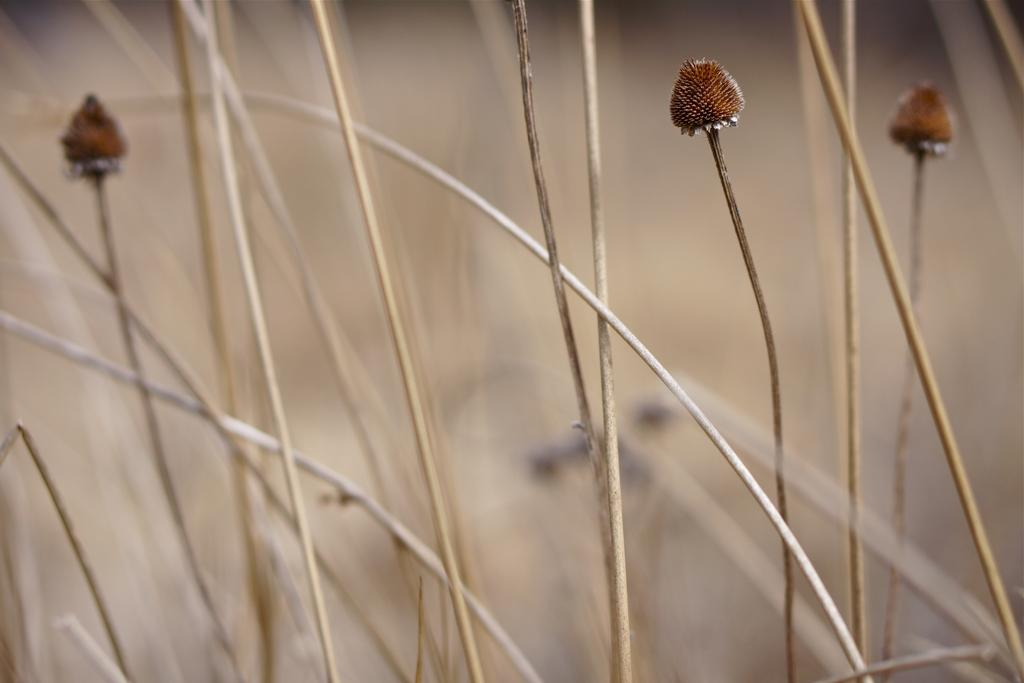How many flower buds can be seen in the image? There are three flower buds in the image. What can be observed in the background of the image? The background of the image is blurry. What type of structure can be seen in the background of the image? There is no structure visible in the background of the image; it is blurry. Where might the flowers be resting in the image? The flowers are not resting in the image; they are in the form of buds. 